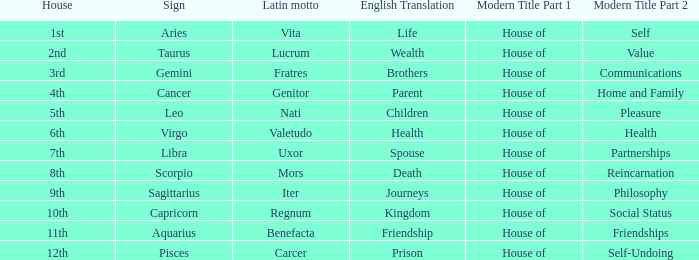Which astrological sign has the Latin motto of Vita? Aries. 